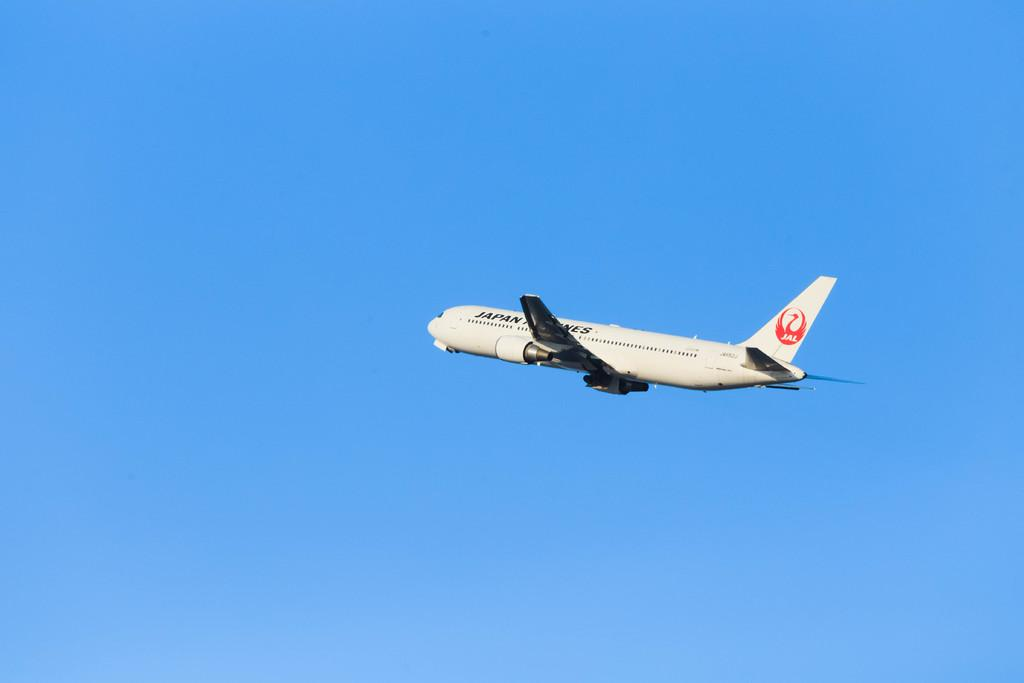What is the main subject of the image? The main subject of the image is an airplane. What is the airplane doing in the image? The airplane is flying. What can be seen in the background of the image? The sky is visible in the background of the image. Can you see any trees or locks in the image? No, there are no trees or locks present in the image. What type of edge can be seen on the airplane in the image? There is no specific edge mentioned or visible in the image; the airplane is simply flying in the sky. 